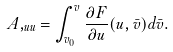<formula> <loc_0><loc_0><loc_500><loc_500>A , _ { u u } = \int _ { v _ { 0 } } ^ { v } \frac { \partial F } { \partial u } ( u , \bar { v } ) d \bar { v } .</formula> 